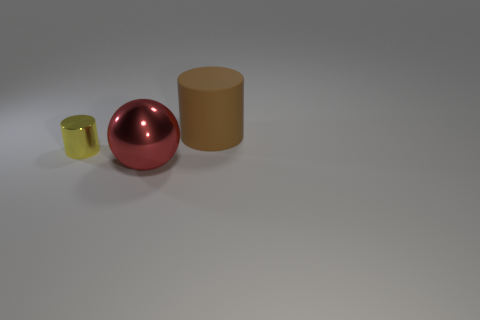Add 1 green objects. How many objects exist? 4 Subtract all spheres. How many objects are left? 2 Add 1 tiny shiny cylinders. How many tiny shiny cylinders are left? 2 Add 2 red metallic things. How many red metallic things exist? 3 Subtract 0 purple balls. How many objects are left? 3 Subtract all large matte things. Subtract all small shiny cylinders. How many objects are left? 1 